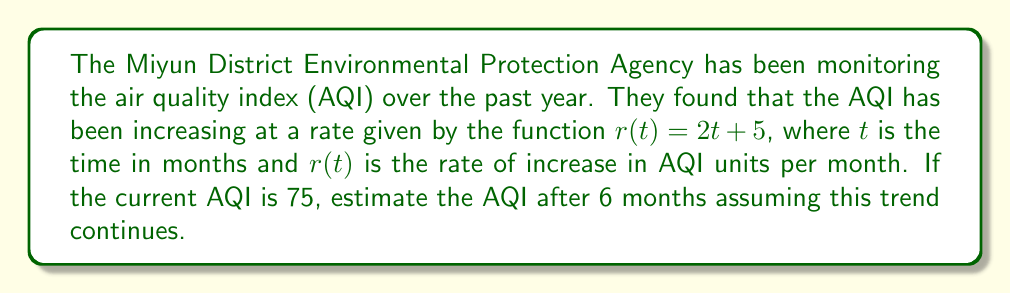Could you help me with this problem? To solve this problem, we need to use integration to find the total increase in AQI over the 6-month period and add it to the current AQI. Here's the step-by-step solution:

1) The rate of increase is given by $r(t) = 2t + 5$.

2) To find the total increase over 6 months, we need to integrate this function from 0 to 6:

   $$\int_0^6 (2t + 5) dt$$

3) Let's solve this integral:
   $$\int_0^6 (2t + 5) dt = [t^2 + 5t]_0^6$$

4) Evaluate the integral:
   $$[t^2 + 5t]_0^6 = (36 + 30) - (0 + 0) = 66$$

5) This means the AQI will increase by 66 units over the 6-month period.

6) The current AQI is 75, so we add 66 to this:

   $$75 + 66 = 141$$

Therefore, the estimated AQI after 6 months is 141.
Answer: 141 